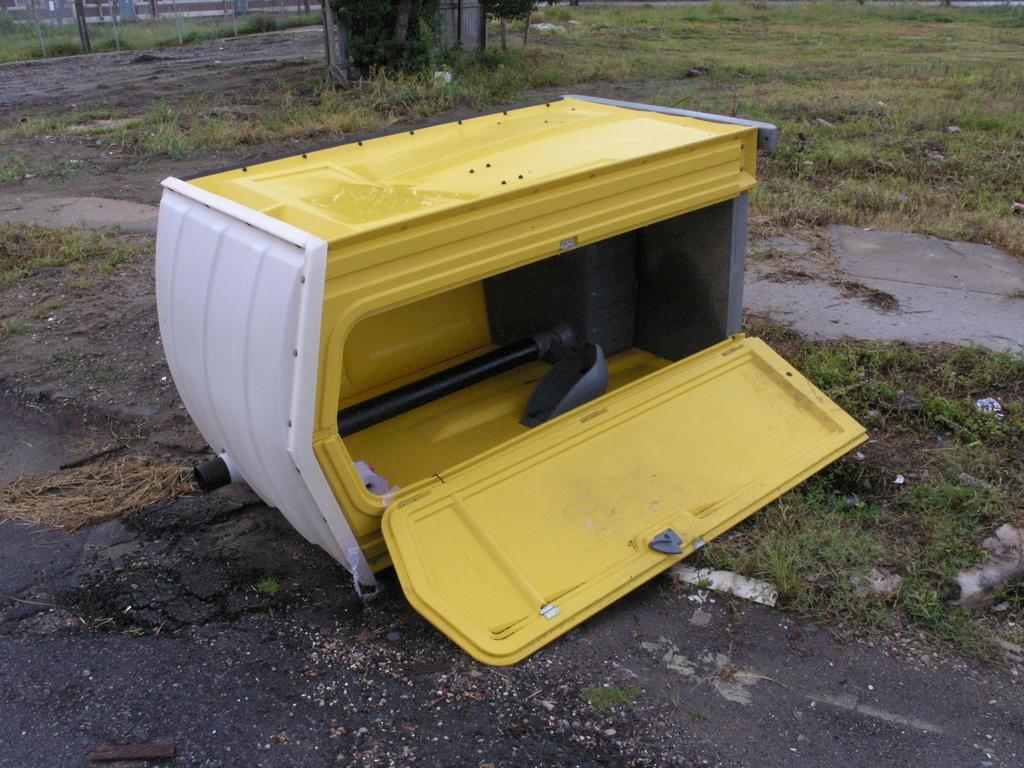Could you give a brief overview of what you see in this image? In this image, we can see a box which is colored white and yellow. There is a grass on the ground. 